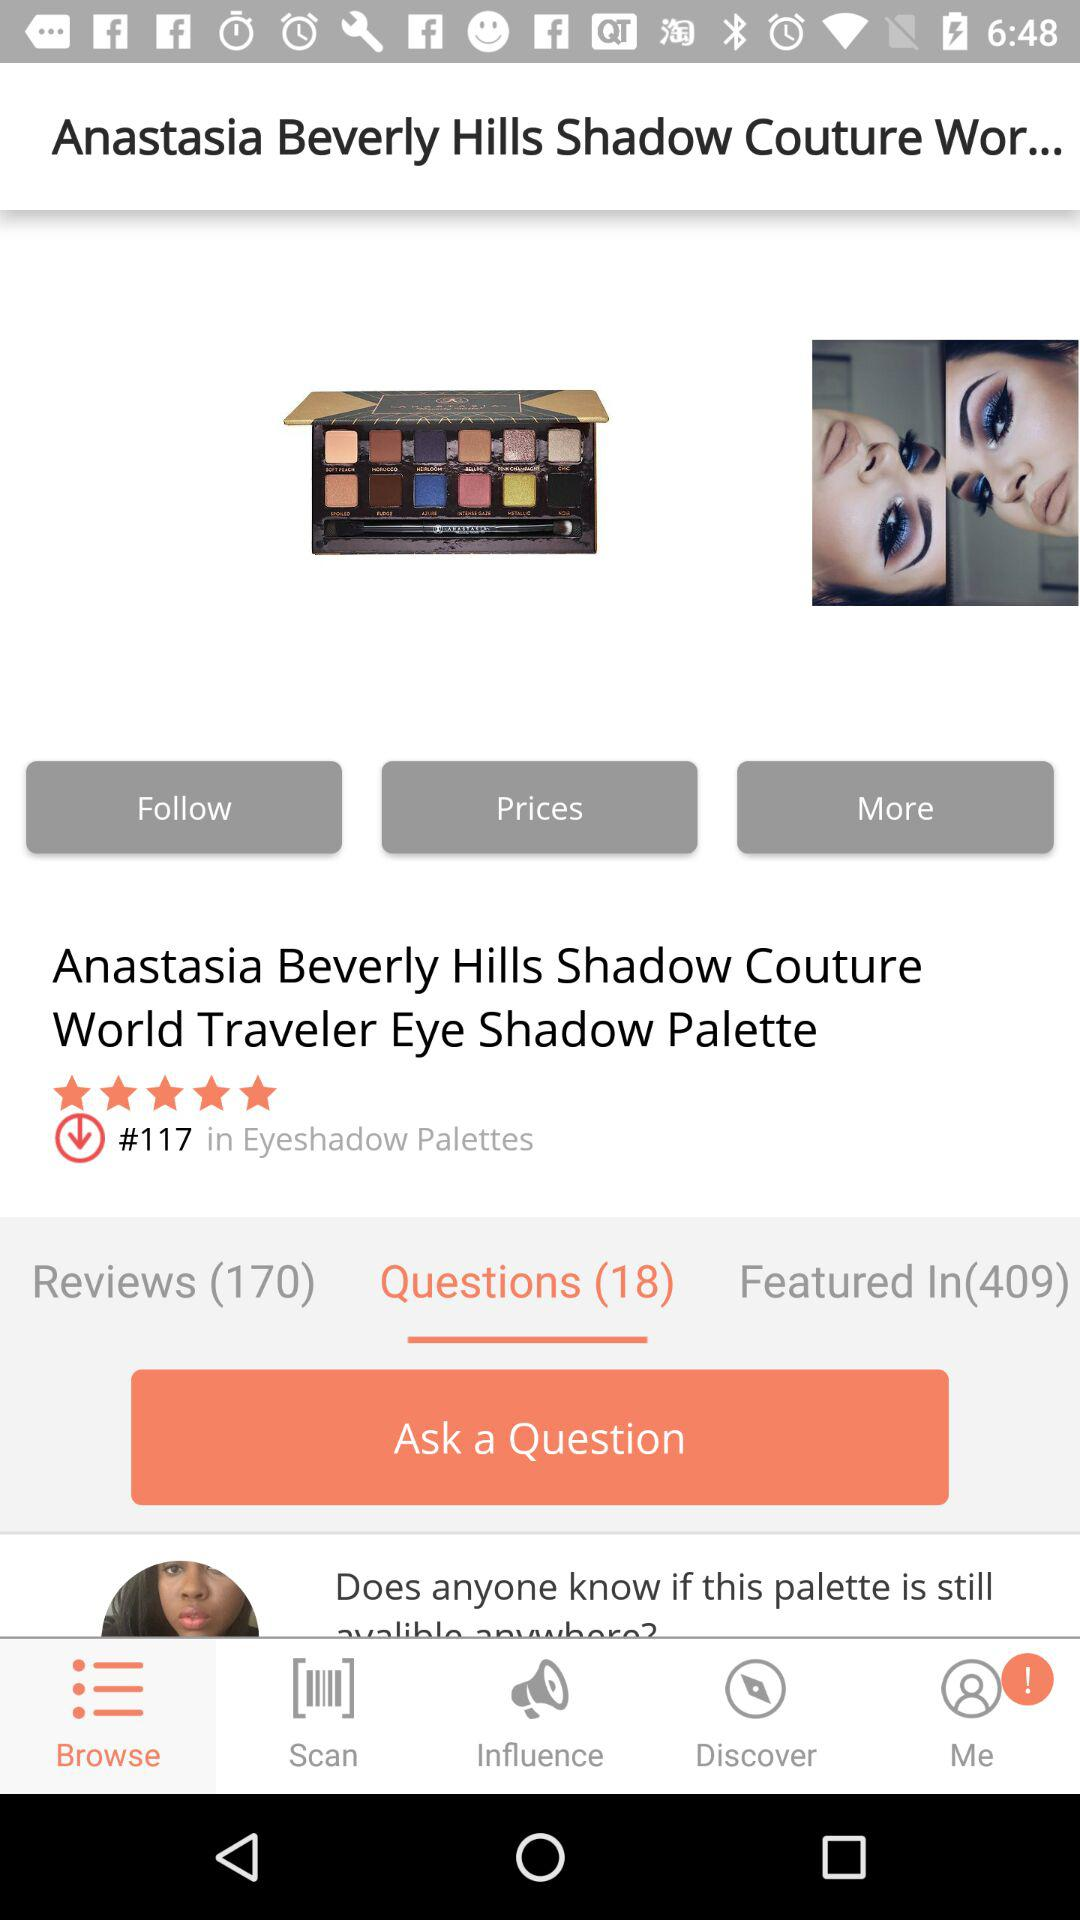How many reviews does the product have?
Answer the question using a single word or phrase. 170 